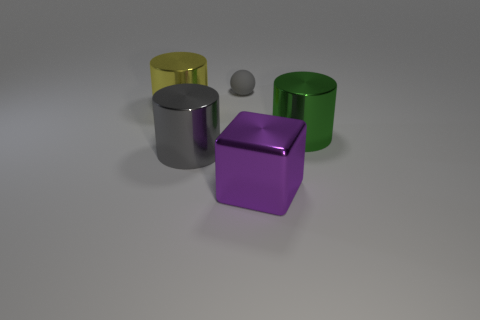There is a gray object left of the small gray matte ball; are there any metallic cylinders that are to the right of it?
Your response must be concise. Yes. What number of other things are there of the same shape as the large gray object?
Provide a short and direct response. 2. Is the shape of the gray metallic thing the same as the large green metallic object?
Ensure brevity in your answer.  Yes. There is a big thing that is in front of the green cylinder and to the left of the block; what color is it?
Offer a terse response. Gray. There is a shiny cylinder that is the same color as the small rubber object; what is its size?
Provide a succinct answer. Large. How many tiny things are either gray cylinders or cyan shiny things?
Give a very brief answer. 0. Is there any other thing that has the same color as the small object?
Keep it short and to the point. Yes. The green cylinder that is to the right of the thing that is behind the big shiny thing behind the large green thing is made of what material?
Make the answer very short. Metal. What number of shiny things are tiny purple things or gray things?
Offer a very short reply. 1. What number of cyan things are either matte things or big objects?
Give a very brief answer. 0. 